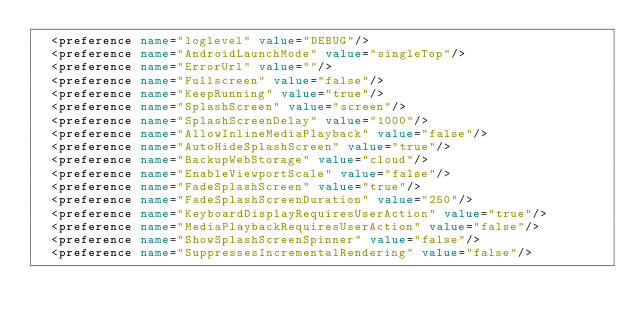<code> <loc_0><loc_0><loc_500><loc_500><_XML_>  <preference name="loglevel" value="DEBUG"/>
  <preference name="AndroidLaunchMode" value="singleTop"/>
  <preference name="ErrorUrl" value=""/>
  <preference name="Fullscreen" value="false"/>
  <preference name="KeepRunning" value="true"/>
  <preference name="SplashScreen" value="screen"/>
  <preference name="SplashScreenDelay" value="1000"/>
  <preference name="AllowInlineMediaPlayback" value="false"/>
  <preference name="AutoHideSplashScreen" value="true"/>
  <preference name="BackupWebStorage" value="cloud"/>
  <preference name="EnableViewportScale" value="false"/>
  <preference name="FadeSplashScreen" value="true"/>
  <preference name="FadeSplashScreenDuration" value="250"/>
  <preference name="KeyboardDisplayRequiresUserAction" value="true"/>
  <preference name="MediaPlaybackRequiresUserAction" value="false"/>
  <preference name="ShowSplashScreenSpinner" value="false"/>
  <preference name="SuppressesIncrementalRendering" value="false"/></code> 